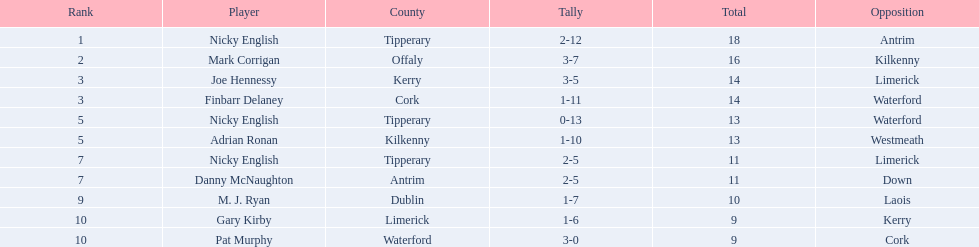What is the total number of points scored by joe hennessy and finbarr delaney? 14. 